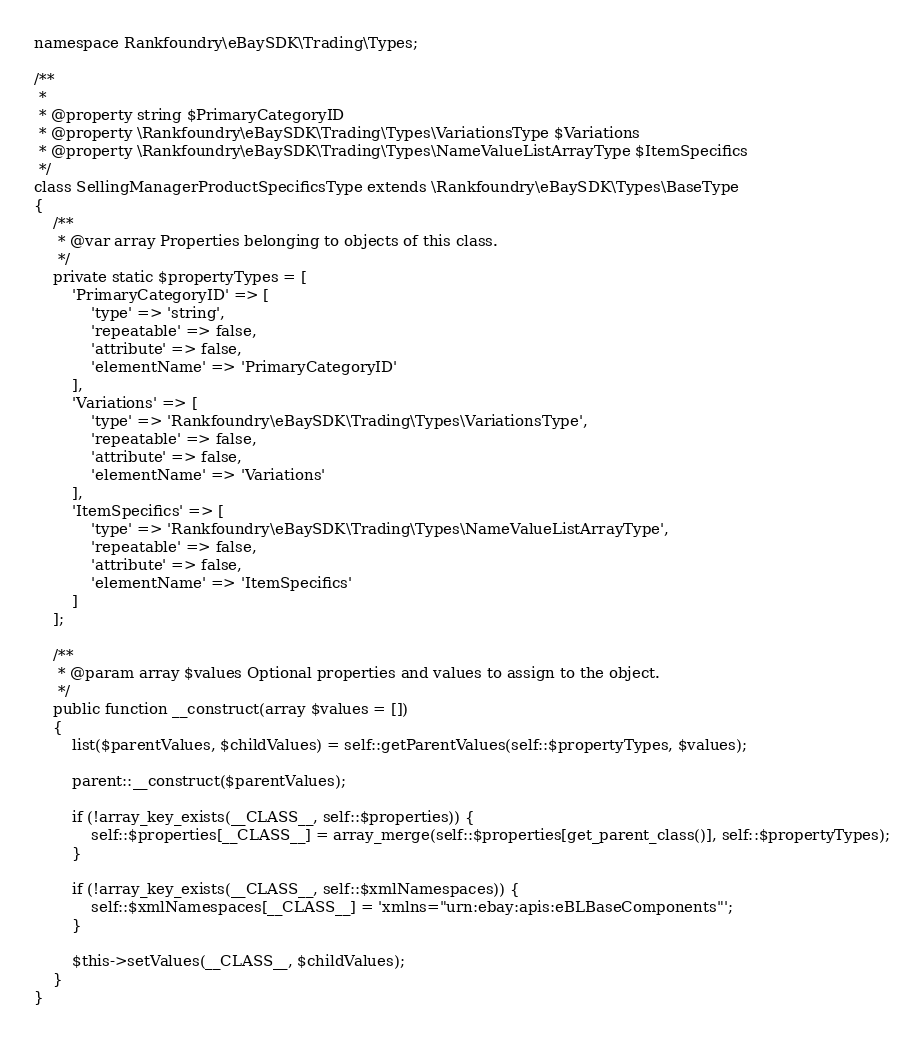Convert code to text. <code><loc_0><loc_0><loc_500><loc_500><_PHP_>
namespace Rankfoundry\eBaySDK\Trading\Types;

/**
 *
 * @property string $PrimaryCategoryID
 * @property \Rankfoundry\eBaySDK\Trading\Types\VariationsType $Variations
 * @property \Rankfoundry\eBaySDK\Trading\Types\NameValueListArrayType $ItemSpecifics
 */
class SellingManagerProductSpecificsType extends \Rankfoundry\eBaySDK\Types\BaseType
{
    /**
     * @var array Properties belonging to objects of this class.
     */
    private static $propertyTypes = [
        'PrimaryCategoryID' => [
            'type' => 'string',
            'repeatable' => false,
            'attribute' => false,
            'elementName' => 'PrimaryCategoryID'
        ],
        'Variations' => [
            'type' => 'Rankfoundry\eBaySDK\Trading\Types\VariationsType',
            'repeatable' => false,
            'attribute' => false,
            'elementName' => 'Variations'
        ],
        'ItemSpecifics' => [
            'type' => 'Rankfoundry\eBaySDK\Trading\Types\NameValueListArrayType',
            'repeatable' => false,
            'attribute' => false,
            'elementName' => 'ItemSpecifics'
        ]
    ];

    /**
     * @param array $values Optional properties and values to assign to the object.
     */
    public function __construct(array $values = [])
    {
        list($parentValues, $childValues) = self::getParentValues(self::$propertyTypes, $values);

        parent::__construct($parentValues);

        if (!array_key_exists(__CLASS__, self::$properties)) {
            self::$properties[__CLASS__] = array_merge(self::$properties[get_parent_class()], self::$propertyTypes);
        }

        if (!array_key_exists(__CLASS__, self::$xmlNamespaces)) {
            self::$xmlNamespaces[__CLASS__] = 'xmlns="urn:ebay:apis:eBLBaseComponents"';
        }

        $this->setValues(__CLASS__, $childValues);
    }
}
</code> 